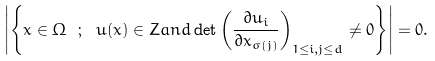<formula> <loc_0><loc_0><loc_500><loc_500>\left | \left \{ x \in \Omega \ ; \ u ( x ) \in Z a n d \det \left ( \frac { \partial u _ { i } } { \partial x _ { \sigma ( j ) } } \right ) _ { 1 \leq i , j \leq d } \not = 0 \right \} \right | = 0 .</formula> 